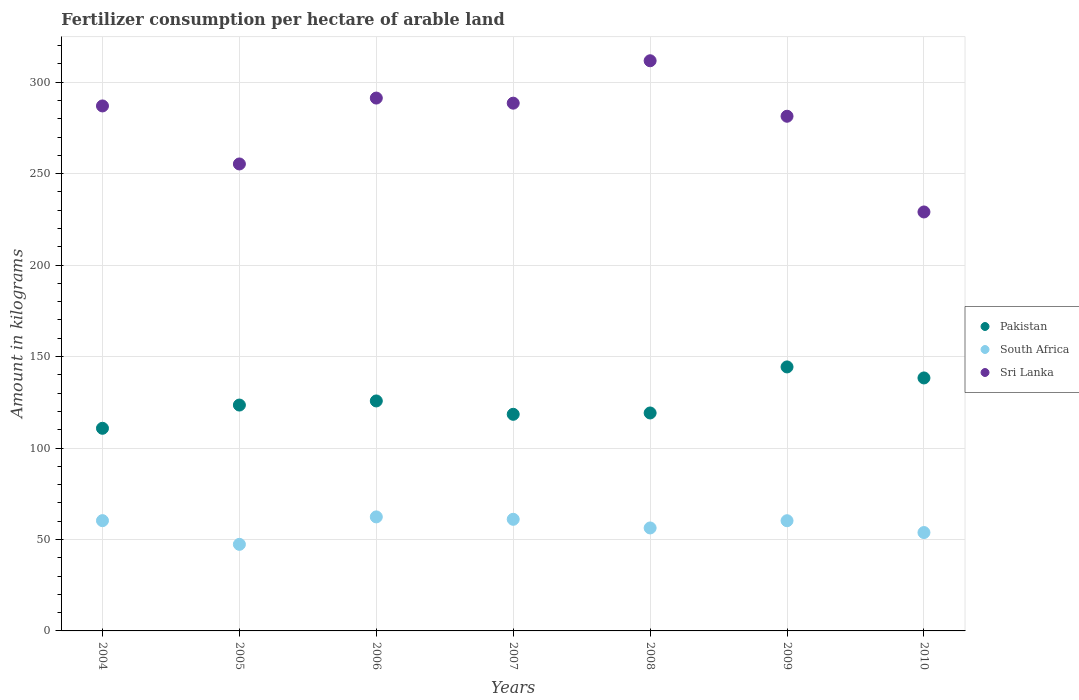Is the number of dotlines equal to the number of legend labels?
Your answer should be very brief. Yes. What is the amount of fertilizer consumption in Sri Lanka in 2005?
Offer a terse response. 255.29. Across all years, what is the maximum amount of fertilizer consumption in Sri Lanka?
Your answer should be compact. 311.71. Across all years, what is the minimum amount of fertilizer consumption in Pakistan?
Make the answer very short. 110.78. What is the total amount of fertilizer consumption in Sri Lanka in the graph?
Provide a succinct answer. 1944.28. What is the difference between the amount of fertilizer consumption in Pakistan in 2005 and that in 2009?
Offer a very short reply. -20.84. What is the difference between the amount of fertilizer consumption in Pakistan in 2010 and the amount of fertilizer consumption in South Africa in 2009?
Provide a succinct answer. 78.06. What is the average amount of fertilizer consumption in South Africa per year?
Make the answer very short. 57.33. In the year 2007, what is the difference between the amount of fertilizer consumption in South Africa and amount of fertilizer consumption in Pakistan?
Your answer should be very brief. -57.4. What is the ratio of the amount of fertilizer consumption in South Africa in 2004 to that in 2009?
Keep it short and to the point. 1. What is the difference between the highest and the second highest amount of fertilizer consumption in South Africa?
Keep it short and to the point. 1.31. What is the difference between the highest and the lowest amount of fertilizer consumption in Pakistan?
Give a very brief answer. 33.55. Is it the case that in every year, the sum of the amount of fertilizer consumption in Pakistan and amount of fertilizer consumption in Sri Lanka  is greater than the amount of fertilizer consumption in South Africa?
Ensure brevity in your answer.  Yes. Is the amount of fertilizer consumption in South Africa strictly less than the amount of fertilizer consumption in Sri Lanka over the years?
Your response must be concise. Yes. What is the difference between two consecutive major ticks on the Y-axis?
Provide a succinct answer. 50. Does the graph contain any zero values?
Ensure brevity in your answer.  No. What is the title of the graph?
Make the answer very short. Fertilizer consumption per hectare of arable land. Does "Dominican Republic" appear as one of the legend labels in the graph?
Provide a succinct answer. No. What is the label or title of the X-axis?
Provide a short and direct response. Years. What is the label or title of the Y-axis?
Give a very brief answer. Amount in kilograms. What is the Amount in kilograms of Pakistan in 2004?
Keep it short and to the point. 110.78. What is the Amount in kilograms in South Africa in 2004?
Offer a very short reply. 60.29. What is the Amount in kilograms of Sri Lanka in 2004?
Provide a succinct answer. 287.01. What is the Amount in kilograms in Pakistan in 2005?
Your answer should be compact. 123.48. What is the Amount in kilograms of South Africa in 2005?
Your response must be concise. 47.33. What is the Amount in kilograms in Sri Lanka in 2005?
Your response must be concise. 255.29. What is the Amount in kilograms in Pakistan in 2006?
Provide a succinct answer. 125.73. What is the Amount in kilograms of South Africa in 2006?
Give a very brief answer. 62.34. What is the Amount in kilograms of Sri Lanka in 2006?
Your response must be concise. 291.32. What is the Amount in kilograms of Pakistan in 2007?
Provide a succinct answer. 118.42. What is the Amount in kilograms of South Africa in 2007?
Your response must be concise. 61.02. What is the Amount in kilograms in Sri Lanka in 2007?
Make the answer very short. 288.52. What is the Amount in kilograms of Pakistan in 2008?
Offer a very short reply. 119.15. What is the Amount in kilograms of South Africa in 2008?
Make the answer very short. 56.29. What is the Amount in kilograms of Sri Lanka in 2008?
Give a very brief answer. 311.71. What is the Amount in kilograms of Pakistan in 2009?
Your answer should be very brief. 144.33. What is the Amount in kilograms of South Africa in 2009?
Give a very brief answer. 60.25. What is the Amount in kilograms in Sri Lanka in 2009?
Make the answer very short. 281.38. What is the Amount in kilograms of Pakistan in 2010?
Your answer should be compact. 138.3. What is the Amount in kilograms of South Africa in 2010?
Your answer should be very brief. 53.78. What is the Amount in kilograms of Sri Lanka in 2010?
Keep it short and to the point. 229.05. Across all years, what is the maximum Amount in kilograms in Pakistan?
Give a very brief answer. 144.33. Across all years, what is the maximum Amount in kilograms in South Africa?
Ensure brevity in your answer.  62.34. Across all years, what is the maximum Amount in kilograms in Sri Lanka?
Provide a succinct answer. 311.71. Across all years, what is the minimum Amount in kilograms in Pakistan?
Keep it short and to the point. 110.78. Across all years, what is the minimum Amount in kilograms in South Africa?
Offer a very short reply. 47.33. Across all years, what is the minimum Amount in kilograms of Sri Lanka?
Offer a very short reply. 229.05. What is the total Amount in kilograms of Pakistan in the graph?
Offer a terse response. 880.2. What is the total Amount in kilograms of South Africa in the graph?
Your response must be concise. 401.3. What is the total Amount in kilograms in Sri Lanka in the graph?
Your answer should be compact. 1944.28. What is the difference between the Amount in kilograms in Pakistan in 2004 and that in 2005?
Ensure brevity in your answer.  -12.7. What is the difference between the Amount in kilograms of South Africa in 2004 and that in 2005?
Provide a short and direct response. 12.96. What is the difference between the Amount in kilograms in Sri Lanka in 2004 and that in 2005?
Offer a very short reply. 31.72. What is the difference between the Amount in kilograms in Pakistan in 2004 and that in 2006?
Offer a very short reply. -14.95. What is the difference between the Amount in kilograms in South Africa in 2004 and that in 2006?
Keep it short and to the point. -2.05. What is the difference between the Amount in kilograms in Sri Lanka in 2004 and that in 2006?
Provide a succinct answer. -4.31. What is the difference between the Amount in kilograms of Pakistan in 2004 and that in 2007?
Your response must be concise. -7.64. What is the difference between the Amount in kilograms in South Africa in 2004 and that in 2007?
Offer a very short reply. -0.73. What is the difference between the Amount in kilograms of Sri Lanka in 2004 and that in 2007?
Make the answer very short. -1.51. What is the difference between the Amount in kilograms in Pakistan in 2004 and that in 2008?
Give a very brief answer. -8.38. What is the difference between the Amount in kilograms of South Africa in 2004 and that in 2008?
Ensure brevity in your answer.  3.99. What is the difference between the Amount in kilograms in Sri Lanka in 2004 and that in 2008?
Make the answer very short. -24.7. What is the difference between the Amount in kilograms in Pakistan in 2004 and that in 2009?
Give a very brief answer. -33.55. What is the difference between the Amount in kilograms of South Africa in 2004 and that in 2009?
Keep it short and to the point. 0.04. What is the difference between the Amount in kilograms in Sri Lanka in 2004 and that in 2009?
Keep it short and to the point. 5.63. What is the difference between the Amount in kilograms of Pakistan in 2004 and that in 2010?
Ensure brevity in your answer.  -27.53. What is the difference between the Amount in kilograms in South Africa in 2004 and that in 2010?
Make the answer very short. 6.51. What is the difference between the Amount in kilograms in Sri Lanka in 2004 and that in 2010?
Make the answer very short. 57.96. What is the difference between the Amount in kilograms in Pakistan in 2005 and that in 2006?
Ensure brevity in your answer.  -2.25. What is the difference between the Amount in kilograms in South Africa in 2005 and that in 2006?
Your response must be concise. -15.01. What is the difference between the Amount in kilograms in Sri Lanka in 2005 and that in 2006?
Provide a succinct answer. -36.02. What is the difference between the Amount in kilograms of Pakistan in 2005 and that in 2007?
Keep it short and to the point. 5.06. What is the difference between the Amount in kilograms in South Africa in 2005 and that in 2007?
Make the answer very short. -13.69. What is the difference between the Amount in kilograms of Sri Lanka in 2005 and that in 2007?
Your answer should be very brief. -33.23. What is the difference between the Amount in kilograms of Pakistan in 2005 and that in 2008?
Make the answer very short. 4.33. What is the difference between the Amount in kilograms of South Africa in 2005 and that in 2008?
Ensure brevity in your answer.  -8.96. What is the difference between the Amount in kilograms in Sri Lanka in 2005 and that in 2008?
Ensure brevity in your answer.  -56.42. What is the difference between the Amount in kilograms of Pakistan in 2005 and that in 2009?
Ensure brevity in your answer.  -20.84. What is the difference between the Amount in kilograms in South Africa in 2005 and that in 2009?
Provide a succinct answer. -12.92. What is the difference between the Amount in kilograms in Sri Lanka in 2005 and that in 2009?
Make the answer very short. -26.08. What is the difference between the Amount in kilograms in Pakistan in 2005 and that in 2010?
Provide a short and direct response. -14.82. What is the difference between the Amount in kilograms in South Africa in 2005 and that in 2010?
Provide a short and direct response. -6.45. What is the difference between the Amount in kilograms in Sri Lanka in 2005 and that in 2010?
Offer a very short reply. 26.24. What is the difference between the Amount in kilograms in Pakistan in 2006 and that in 2007?
Keep it short and to the point. 7.31. What is the difference between the Amount in kilograms of South Africa in 2006 and that in 2007?
Provide a short and direct response. 1.31. What is the difference between the Amount in kilograms in Sri Lanka in 2006 and that in 2007?
Your answer should be very brief. 2.79. What is the difference between the Amount in kilograms of Pakistan in 2006 and that in 2008?
Offer a very short reply. 6.58. What is the difference between the Amount in kilograms of South Africa in 2006 and that in 2008?
Keep it short and to the point. 6.04. What is the difference between the Amount in kilograms in Sri Lanka in 2006 and that in 2008?
Keep it short and to the point. -20.4. What is the difference between the Amount in kilograms of Pakistan in 2006 and that in 2009?
Make the answer very short. -18.6. What is the difference between the Amount in kilograms of South Africa in 2006 and that in 2009?
Give a very brief answer. 2.09. What is the difference between the Amount in kilograms in Sri Lanka in 2006 and that in 2009?
Ensure brevity in your answer.  9.94. What is the difference between the Amount in kilograms in Pakistan in 2006 and that in 2010?
Provide a succinct answer. -12.57. What is the difference between the Amount in kilograms in South Africa in 2006 and that in 2010?
Offer a terse response. 8.56. What is the difference between the Amount in kilograms of Sri Lanka in 2006 and that in 2010?
Offer a very short reply. 62.27. What is the difference between the Amount in kilograms of Pakistan in 2007 and that in 2008?
Your answer should be very brief. -0.73. What is the difference between the Amount in kilograms in South Africa in 2007 and that in 2008?
Ensure brevity in your answer.  4.73. What is the difference between the Amount in kilograms of Sri Lanka in 2007 and that in 2008?
Your response must be concise. -23.19. What is the difference between the Amount in kilograms in Pakistan in 2007 and that in 2009?
Give a very brief answer. -25.9. What is the difference between the Amount in kilograms of South Africa in 2007 and that in 2009?
Ensure brevity in your answer.  0.77. What is the difference between the Amount in kilograms in Sri Lanka in 2007 and that in 2009?
Provide a succinct answer. 7.15. What is the difference between the Amount in kilograms in Pakistan in 2007 and that in 2010?
Provide a succinct answer. -19.88. What is the difference between the Amount in kilograms in South Africa in 2007 and that in 2010?
Make the answer very short. 7.24. What is the difference between the Amount in kilograms of Sri Lanka in 2007 and that in 2010?
Make the answer very short. 59.48. What is the difference between the Amount in kilograms in Pakistan in 2008 and that in 2009?
Ensure brevity in your answer.  -25.17. What is the difference between the Amount in kilograms of South Africa in 2008 and that in 2009?
Your answer should be compact. -3.95. What is the difference between the Amount in kilograms in Sri Lanka in 2008 and that in 2009?
Your response must be concise. 30.34. What is the difference between the Amount in kilograms of Pakistan in 2008 and that in 2010?
Give a very brief answer. -19.15. What is the difference between the Amount in kilograms of South Africa in 2008 and that in 2010?
Make the answer very short. 2.51. What is the difference between the Amount in kilograms of Sri Lanka in 2008 and that in 2010?
Make the answer very short. 82.66. What is the difference between the Amount in kilograms of Pakistan in 2009 and that in 2010?
Your answer should be very brief. 6.02. What is the difference between the Amount in kilograms of South Africa in 2009 and that in 2010?
Make the answer very short. 6.47. What is the difference between the Amount in kilograms in Sri Lanka in 2009 and that in 2010?
Offer a very short reply. 52.33. What is the difference between the Amount in kilograms in Pakistan in 2004 and the Amount in kilograms in South Africa in 2005?
Make the answer very short. 63.45. What is the difference between the Amount in kilograms of Pakistan in 2004 and the Amount in kilograms of Sri Lanka in 2005?
Offer a very short reply. -144.51. What is the difference between the Amount in kilograms in South Africa in 2004 and the Amount in kilograms in Sri Lanka in 2005?
Ensure brevity in your answer.  -195. What is the difference between the Amount in kilograms in Pakistan in 2004 and the Amount in kilograms in South Africa in 2006?
Make the answer very short. 48.44. What is the difference between the Amount in kilograms of Pakistan in 2004 and the Amount in kilograms of Sri Lanka in 2006?
Your answer should be compact. -180.54. What is the difference between the Amount in kilograms in South Africa in 2004 and the Amount in kilograms in Sri Lanka in 2006?
Your answer should be very brief. -231.03. What is the difference between the Amount in kilograms in Pakistan in 2004 and the Amount in kilograms in South Africa in 2007?
Provide a short and direct response. 49.76. What is the difference between the Amount in kilograms of Pakistan in 2004 and the Amount in kilograms of Sri Lanka in 2007?
Offer a very short reply. -177.75. What is the difference between the Amount in kilograms in South Africa in 2004 and the Amount in kilograms in Sri Lanka in 2007?
Your answer should be very brief. -228.24. What is the difference between the Amount in kilograms in Pakistan in 2004 and the Amount in kilograms in South Africa in 2008?
Provide a short and direct response. 54.49. What is the difference between the Amount in kilograms in Pakistan in 2004 and the Amount in kilograms in Sri Lanka in 2008?
Your answer should be compact. -200.93. What is the difference between the Amount in kilograms of South Africa in 2004 and the Amount in kilograms of Sri Lanka in 2008?
Keep it short and to the point. -251.42. What is the difference between the Amount in kilograms in Pakistan in 2004 and the Amount in kilograms in South Africa in 2009?
Your answer should be very brief. 50.53. What is the difference between the Amount in kilograms in Pakistan in 2004 and the Amount in kilograms in Sri Lanka in 2009?
Keep it short and to the point. -170.6. What is the difference between the Amount in kilograms of South Africa in 2004 and the Amount in kilograms of Sri Lanka in 2009?
Offer a very short reply. -221.09. What is the difference between the Amount in kilograms in Pakistan in 2004 and the Amount in kilograms in South Africa in 2010?
Your response must be concise. 57. What is the difference between the Amount in kilograms in Pakistan in 2004 and the Amount in kilograms in Sri Lanka in 2010?
Keep it short and to the point. -118.27. What is the difference between the Amount in kilograms in South Africa in 2004 and the Amount in kilograms in Sri Lanka in 2010?
Your answer should be very brief. -168.76. What is the difference between the Amount in kilograms in Pakistan in 2005 and the Amount in kilograms in South Africa in 2006?
Your answer should be compact. 61.15. What is the difference between the Amount in kilograms in Pakistan in 2005 and the Amount in kilograms in Sri Lanka in 2006?
Provide a short and direct response. -167.83. What is the difference between the Amount in kilograms of South Africa in 2005 and the Amount in kilograms of Sri Lanka in 2006?
Provide a short and direct response. -243.98. What is the difference between the Amount in kilograms in Pakistan in 2005 and the Amount in kilograms in South Africa in 2007?
Offer a very short reply. 62.46. What is the difference between the Amount in kilograms in Pakistan in 2005 and the Amount in kilograms in Sri Lanka in 2007?
Your answer should be compact. -165.04. What is the difference between the Amount in kilograms of South Africa in 2005 and the Amount in kilograms of Sri Lanka in 2007?
Your response must be concise. -241.19. What is the difference between the Amount in kilograms of Pakistan in 2005 and the Amount in kilograms of South Africa in 2008?
Your response must be concise. 67.19. What is the difference between the Amount in kilograms of Pakistan in 2005 and the Amount in kilograms of Sri Lanka in 2008?
Offer a terse response. -188.23. What is the difference between the Amount in kilograms in South Africa in 2005 and the Amount in kilograms in Sri Lanka in 2008?
Offer a terse response. -264.38. What is the difference between the Amount in kilograms in Pakistan in 2005 and the Amount in kilograms in South Africa in 2009?
Give a very brief answer. 63.24. What is the difference between the Amount in kilograms in Pakistan in 2005 and the Amount in kilograms in Sri Lanka in 2009?
Give a very brief answer. -157.89. What is the difference between the Amount in kilograms of South Africa in 2005 and the Amount in kilograms of Sri Lanka in 2009?
Keep it short and to the point. -234.05. What is the difference between the Amount in kilograms of Pakistan in 2005 and the Amount in kilograms of South Africa in 2010?
Offer a very short reply. 69.7. What is the difference between the Amount in kilograms in Pakistan in 2005 and the Amount in kilograms in Sri Lanka in 2010?
Provide a short and direct response. -105.56. What is the difference between the Amount in kilograms in South Africa in 2005 and the Amount in kilograms in Sri Lanka in 2010?
Offer a terse response. -181.72. What is the difference between the Amount in kilograms in Pakistan in 2006 and the Amount in kilograms in South Africa in 2007?
Offer a terse response. 64.71. What is the difference between the Amount in kilograms in Pakistan in 2006 and the Amount in kilograms in Sri Lanka in 2007?
Keep it short and to the point. -162.79. What is the difference between the Amount in kilograms of South Africa in 2006 and the Amount in kilograms of Sri Lanka in 2007?
Provide a succinct answer. -226.19. What is the difference between the Amount in kilograms of Pakistan in 2006 and the Amount in kilograms of South Africa in 2008?
Offer a terse response. 69.44. What is the difference between the Amount in kilograms of Pakistan in 2006 and the Amount in kilograms of Sri Lanka in 2008?
Your response must be concise. -185.98. What is the difference between the Amount in kilograms of South Africa in 2006 and the Amount in kilograms of Sri Lanka in 2008?
Offer a terse response. -249.38. What is the difference between the Amount in kilograms in Pakistan in 2006 and the Amount in kilograms in South Africa in 2009?
Offer a terse response. 65.48. What is the difference between the Amount in kilograms of Pakistan in 2006 and the Amount in kilograms of Sri Lanka in 2009?
Ensure brevity in your answer.  -155.65. What is the difference between the Amount in kilograms in South Africa in 2006 and the Amount in kilograms in Sri Lanka in 2009?
Give a very brief answer. -219.04. What is the difference between the Amount in kilograms in Pakistan in 2006 and the Amount in kilograms in South Africa in 2010?
Keep it short and to the point. 71.95. What is the difference between the Amount in kilograms in Pakistan in 2006 and the Amount in kilograms in Sri Lanka in 2010?
Your response must be concise. -103.32. What is the difference between the Amount in kilograms of South Africa in 2006 and the Amount in kilograms of Sri Lanka in 2010?
Provide a short and direct response. -166.71. What is the difference between the Amount in kilograms of Pakistan in 2007 and the Amount in kilograms of South Africa in 2008?
Your response must be concise. 62.13. What is the difference between the Amount in kilograms of Pakistan in 2007 and the Amount in kilograms of Sri Lanka in 2008?
Provide a short and direct response. -193.29. What is the difference between the Amount in kilograms in South Africa in 2007 and the Amount in kilograms in Sri Lanka in 2008?
Keep it short and to the point. -250.69. What is the difference between the Amount in kilograms in Pakistan in 2007 and the Amount in kilograms in South Africa in 2009?
Provide a succinct answer. 58.18. What is the difference between the Amount in kilograms in Pakistan in 2007 and the Amount in kilograms in Sri Lanka in 2009?
Your answer should be very brief. -162.95. What is the difference between the Amount in kilograms in South Africa in 2007 and the Amount in kilograms in Sri Lanka in 2009?
Provide a succinct answer. -220.35. What is the difference between the Amount in kilograms in Pakistan in 2007 and the Amount in kilograms in South Africa in 2010?
Make the answer very short. 64.64. What is the difference between the Amount in kilograms of Pakistan in 2007 and the Amount in kilograms of Sri Lanka in 2010?
Offer a very short reply. -110.62. What is the difference between the Amount in kilograms of South Africa in 2007 and the Amount in kilograms of Sri Lanka in 2010?
Keep it short and to the point. -168.03. What is the difference between the Amount in kilograms of Pakistan in 2008 and the Amount in kilograms of South Africa in 2009?
Give a very brief answer. 58.91. What is the difference between the Amount in kilograms in Pakistan in 2008 and the Amount in kilograms in Sri Lanka in 2009?
Provide a short and direct response. -162.22. What is the difference between the Amount in kilograms in South Africa in 2008 and the Amount in kilograms in Sri Lanka in 2009?
Your answer should be compact. -225.08. What is the difference between the Amount in kilograms in Pakistan in 2008 and the Amount in kilograms in South Africa in 2010?
Keep it short and to the point. 65.37. What is the difference between the Amount in kilograms in Pakistan in 2008 and the Amount in kilograms in Sri Lanka in 2010?
Your response must be concise. -109.89. What is the difference between the Amount in kilograms of South Africa in 2008 and the Amount in kilograms of Sri Lanka in 2010?
Offer a terse response. -172.75. What is the difference between the Amount in kilograms in Pakistan in 2009 and the Amount in kilograms in South Africa in 2010?
Ensure brevity in your answer.  90.55. What is the difference between the Amount in kilograms of Pakistan in 2009 and the Amount in kilograms of Sri Lanka in 2010?
Offer a terse response. -84.72. What is the difference between the Amount in kilograms of South Africa in 2009 and the Amount in kilograms of Sri Lanka in 2010?
Keep it short and to the point. -168.8. What is the average Amount in kilograms of Pakistan per year?
Your answer should be compact. 125.74. What is the average Amount in kilograms of South Africa per year?
Ensure brevity in your answer.  57.33. What is the average Amount in kilograms of Sri Lanka per year?
Provide a succinct answer. 277.75. In the year 2004, what is the difference between the Amount in kilograms in Pakistan and Amount in kilograms in South Africa?
Your response must be concise. 50.49. In the year 2004, what is the difference between the Amount in kilograms in Pakistan and Amount in kilograms in Sri Lanka?
Provide a succinct answer. -176.23. In the year 2004, what is the difference between the Amount in kilograms in South Africa and Amount in kilograms in Sri Lanka?
Offer a very short reply. -226.72. In the year 2005, what is the difference between the Amount in kilograms of Pakistan and Amount in kilograms of South Africa?
Provide a short and direct response. 76.15. In the year 2005, what is the difference between the Amount in kilograms in Pakistan and Amount in kilograms in Sri Lanka?
Your answer should be very brief. -131.81. In the year 2005, what is the difference between the Amount in kilograms in South Africa and Amount in kilograms in Sri Lanka?
Keep it short and to the point. -207.96. In the year 2006, what is the difference between the Amount in kilograms of Pakistan and Amount in kilograms of South Africa?
Your response must be concise. 63.39. In the year 2006, what is the difference between the Amount in kilograms of Pakistan and Amount in kilograms of Sri Lanka?
Ensure brevity in your answer.  -165.59. In the year 2006, what is the difference between the Amount in kilograms in South Africa and Amount in kilograms in Sri Lanka?
Make the answer very short. -228.98. In the year 2007, what is the difference between the Amount in kilograms of Pakistan and Amount in kilograms of South Africa?
Give a very brief answer. 57.4. In the year 2007, what is the difference between the Amount in kilograms in Pakistan and Amount in kilograms in Sri Lanka?
Provide a succinct answer. -170.1. In the year 2007, what is the difference between the Amount in kilograms of South Africa and Amount in kilograms of Sri Lanka?
Provide a succinct answer. -227.5. In the year 2008, what is the difference between the Amount in kilograms of Pakistan and Amount in kilograms of South Africa?
Make the answer very short. 62.86. In the year 2008, what is the difference between the Amount in kilograms in Pakistan and Amount in kilograms in Sri Lanka?
Make the answer very short. -192.56. In the year 2008, what is the difference between the Amount in kilograms in South Africa and Amount in kilograms in Sri Lanka?
Your answer should be compact. -255.42. In the year 2009, what is the difference between the Amount in kilograms of Pakistan and Amount in kilograms of South Africa?
Give a very brief answer. 84.08. In the year 2009, what is the difference between the Amount in kilograms of Pakistan and Amount in kilograms of Sri Lanka?
Offer a very short reply. -137.05. In the year 2009, what is the difference between the Amount in kilograms in South Africa and Amount in kilograms in Sri Lanka?
Make the answer very short. -221.13. In the year 2010, what is the difference between the Amount in kilograms of Pakistan and Amount in kilograms of South Africa?
Make the answer very short. 84.52. In the year 2010, what is the difference between the Amount in kilograms in Pakistan and Amount in kilograms in Sri Lanka?
Give a very brief answer. -90.74. In the year 2010, what is the difference between the Amount in kilograms of South Africa and Amount in kilograms of Sri Lanka?
Your response must be concise. -175.27. What is the ratio of the Amount in kilograms in Pakistan in 2004 to that in 2005?
Offer a terse response. 0.9. What is the ratio of the Amount in kilograms of South Africa in 2004 to that in 2005?
Provide a succinct answer. 1.27. What is the ratio of the Amount in kilograms in Sri Lanka in 2004 to that in 2005?
Make the answer very short. 1.12. What is the ratio of the Amount in kilograms in Pakistan in 2004 to that in 2006?
Your answer should be very brief. 0.88. What is the ratio of the Amount in kilograms of South Africa in 2004 to that in 2006?
Offer a terse response. 0.97. What is the ratio of the Amount in kilograms in Sri Lanka in 2004 to that in 2006?
Keep it short and to the point. 0.99. What is the ratio of the Amount in kilograms in Pakistan in 2004 to that in 2007?
Your answer should be very brief. 0.94. What is the ratio of the Amount in kilograms of Pakistan in 2004 to that in 2008?
Provide a succinct answer. 0.93. What is the ratio of the Amount in kilograms in South Africa in 2004 to that in 2008?
Your response must be concise. 1.07. What is the ratio of the Amount in kilograms in Sri Lanka in 2004 to that in 2008?
Offer a terse response. 0.92. What is the ratio of the Amount in kilograms in Pakistan in 2004 to that in 2009?
Give a very brief answer. 0.77. What is the ratio of the Amount in kilograms in Sri Lanka in 2004 to that in 2009?
Offer a terse response. 1.02. What is the ratio of the Amount in kilograms in Pakistan in 2004 to that in 2010?
Your response must be concise. 0.8. What is the ratio of the Amount in kilograms of South Africa in 2004 to that in 2010?
Offer a terse response. 1.12. What is the ratio of the Amount in kilograms of Sri Lanka in 2004 to that in 2010?
Ensure brevity in your answer.  1.25. What is the ratio of the Amount in kilograms in Pakistan in 2005 to that in 2006?
Provide a succinct answer. 0.98. What is the ratio of the Amount in kilograms in South Africa in 2005 to that in 2006?
Offer a very short reply. 0.76. What is the ratio of the Amount in kilograms in Sri Lanka in 2005 to that in 2006?
Ensure brevity in your answer.  0.88. What is the ratio of the Amount in kilograms of Pakistan in 2005 to that in 2007?
Ensure brevity in your answer.  1.04. What is the ratio of the Amount in kilograms of South Africa in 2005 to that in 2007?
Keep it short and to the point. 0.78. What is the ratio of the Amount in kilograms of Sri Lanka in 2005 to that in 2007?
Provide a short and direct response. 0.88. What is the ratio of the Amount in kilograms of Pakistan in 2005 to that in 2008?
Your answer should be compact. 1.04. What is the ratio of the Amount in kilograms of South Africa in 2005 to that in 2008?
Your answer should be very brief. 0.84. What is the ratio of the Amount in kilograms of Sri Lanka in 2005 to that in 2008?
Keep it short and to the point. 0.82. What is the ratio of the Amount in kilograms of Pakistan in 2005 to that in 2009?
Ensure brevity in your answer.  0.86. What is the ratio of the Amount in kilograms in South Africa in 2005 to that in 2009?
Give a very brief answer. 0.79. What is the ratio of the Amount in kilograms in Sri Lanka in 2005 to that in 2009?
Your answer should be compact. 0.91. What is the ratio of the Amount in kilograms of Pakistan in 2005 to that in 2010?
Provide a succinct answer. 0.89. What is the ratio of the Amount in kilograms of South Africa in 2005 to that in 2010?
Keep it short and to the point. 0.88. What is the ratio of the Amount in kilograms in Sri Lanka in 2005 to that in 2010?
Ensure brevity in your answer.  1.11. What is the ratio of the Amount in kilograms of Pakistan in 2006 to that in 2007?
Your answer should be very brief. 1.06. What is the ratio of the Amount in kilograms of South Africa in 2006 to that in 2007?
Ensure brevity in your answer.  1.02. What is the ratio of the Amount in kilograms in Sri Lanka in 2006 to that in 2007?
Ensure brevity in your answer.  1.01. What is the ratio of the Amount in kilograms in Pakistan in 2006 to that in 2008?
Make the answer very short. 1.06. What is the ratio of the Amount in kilograms of South Africa in 2006 to that in 2008?
Make the answer very short. 1.11. What is the ratio of the Amount in kilograms in Sri Lanka in 2006 to that in 2008?
Offer a terse response. 0.93. What is the ratio of the Amount in kilograms in Pakistan in 2006 to that in 2009?
Ensure brevity in your answer.  0.87. What is the ratio of the Amount in kilograms in South Africa in 2006 to that in 2009?
Your answer should be compact. 1.03. What is the ratio of the Amount in kilograms in Sri Lanka in 2006 to that in 2009?
Your response must be concise. 1.04. What is the ratio of the Amount in kilograms of Pakistan in 2006 to that in 2010?
Keep it short and to the point. 0.91. What is the ratio of the Amount in kilograms of South Africa in 2006 to that in 2010?
Ensure brevity in your answer.  1.16. What is the ratio of the Amount in kilograms in Sri Lanka in 2006 to that in 2010?
Your response must be concise. 1.27. What is the ratio of the Amount in kilograms of Pakistan in 2007 to that in 2008?
Offer a terse response. 0.99. What is the ratio of the Amount in kilograms in South Africa in 2007 to that in 2008?
Offer a very short reply. 1.08. What is the ratio of the Amount in kilograms in Sri Lanka in 2007 to that in 2008?
Your response must be concise. 0.93. What is the ratio of the Amount in kilograms in Pakistan in 2007 to that in 2009?
Provide a succinct answer. 0.82. What is the ratio of the Amount in kilograms in South Africa in 2007 to that in 2009?
Your response must be concise. 1.01. What is the ratio of the Amount in kilograms in Sri Lanka in 2007 to that in 2009?
Offer a very short reply. 1.03. What is the ratio of the Amount in kilograms in Pakistan in 2007 to that in 2010?
Offer a very short reply. 0.86. What is the ratio of the Amount in kilograms in South Africa in 2007 to that in 2010?
Ensure brevity in your answer.  1.13. What is the ratio of the Amount in kilograms of Sri Lanka in 2007 to that in 2010?
Your answer should be compact. 1.26. What is the ratio of the Amount in kilograms of Pakistan in 2008 to that in 2009?
Keep it short and to the point. 0.83. What is the ratio of the Amount in kilograms in South Africa in 2008 to that in 2009?
Your answer should be compact. 0.93. What is the ratio of the Amount in kilograms in Sri Lanka in 2008 to that in 2009?
Your response must be concise. 1.11. What is the ratio of the Amount in kilograms of Pakistan in 2008 to that in 2010?
Make the answer very short. 0.86. What is the ratio of the Amount in kilograms in South Africa in 2008 to that in 2010?
Offer a very short reply. 1.05. What is the ratio of the Amount in kilograms in Sri Lanka in 2008 to that in 2010?
Offer a very short reply. 1.36. What is the ratio of the Amount in kilograms in Pakistan in 2009 to that in 2010?
Your answer should be compact. 1.04. What is the ratio of the Amount in kilograms of South Africa in 2009 to that in 2010?
Provide a succinct answer. 1.12. What is the ratio of the Amount in kilograms of Sri Lanka in 2009 to that in 2010?
Your answer should be compact. 1.23. What is the difference between the highest and the second highest Amount in kilograms of Pakistan?
Provide a short and direct response. 6.02. What is the difference between the highest and the second highest Amount in kilograms in South Africa?
Offer a terse response. 1.31. What is the difference between the highest and the second highest Amount in kilograms in Sri Lanka?
Give a very brief answer. 20.4. What is the difference between the highest and the lowest Amount in kilograms in Pakistan?
Keep it short and to the point. 33.55. What is the difference between the highest and the lowest Amount in kilograms in South Africa?
Provide a succinct answer. 15.01. What is the difference between the highest and the lowest Amount in kilograms of Sri Lanka?
Provide a succinct answer. 82.66. 